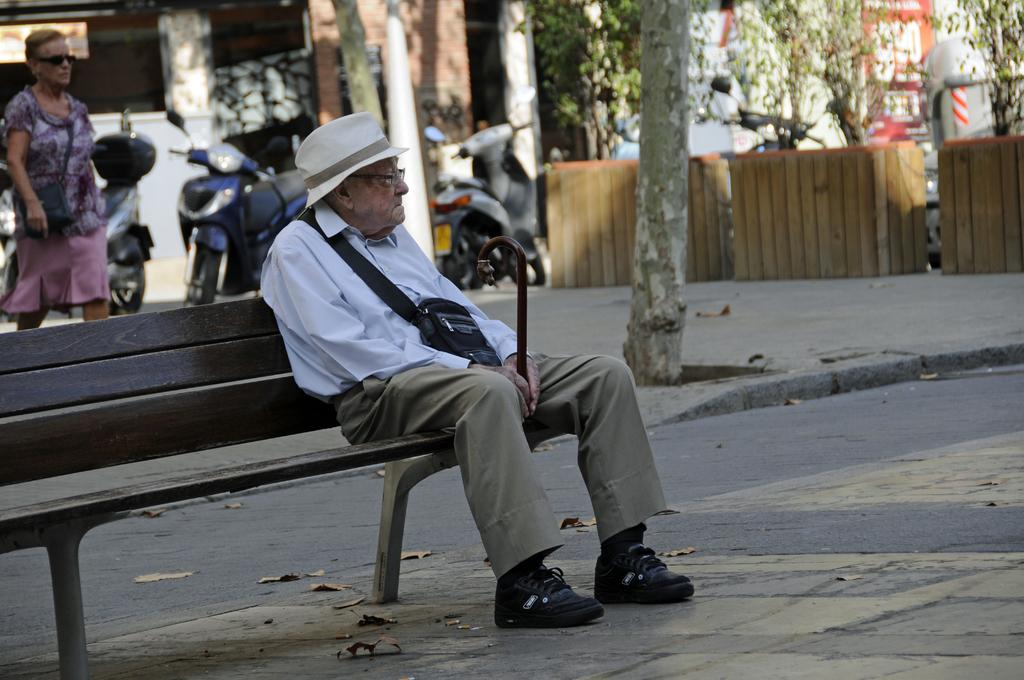What is the main subject of the image? There is a person sitting on a bench in the image. Can you describe the person's surroundings? There is a person walking behind the person sitting on the bench, and trees, vehicles, and a building are visible to the right of the image. What type of stomach ache is the person sitting on the bench experiencing in the image? There is no indication in the image that the person sitting on the bench is experiencing a stomach ache, so it cannot be determined from the picture. 